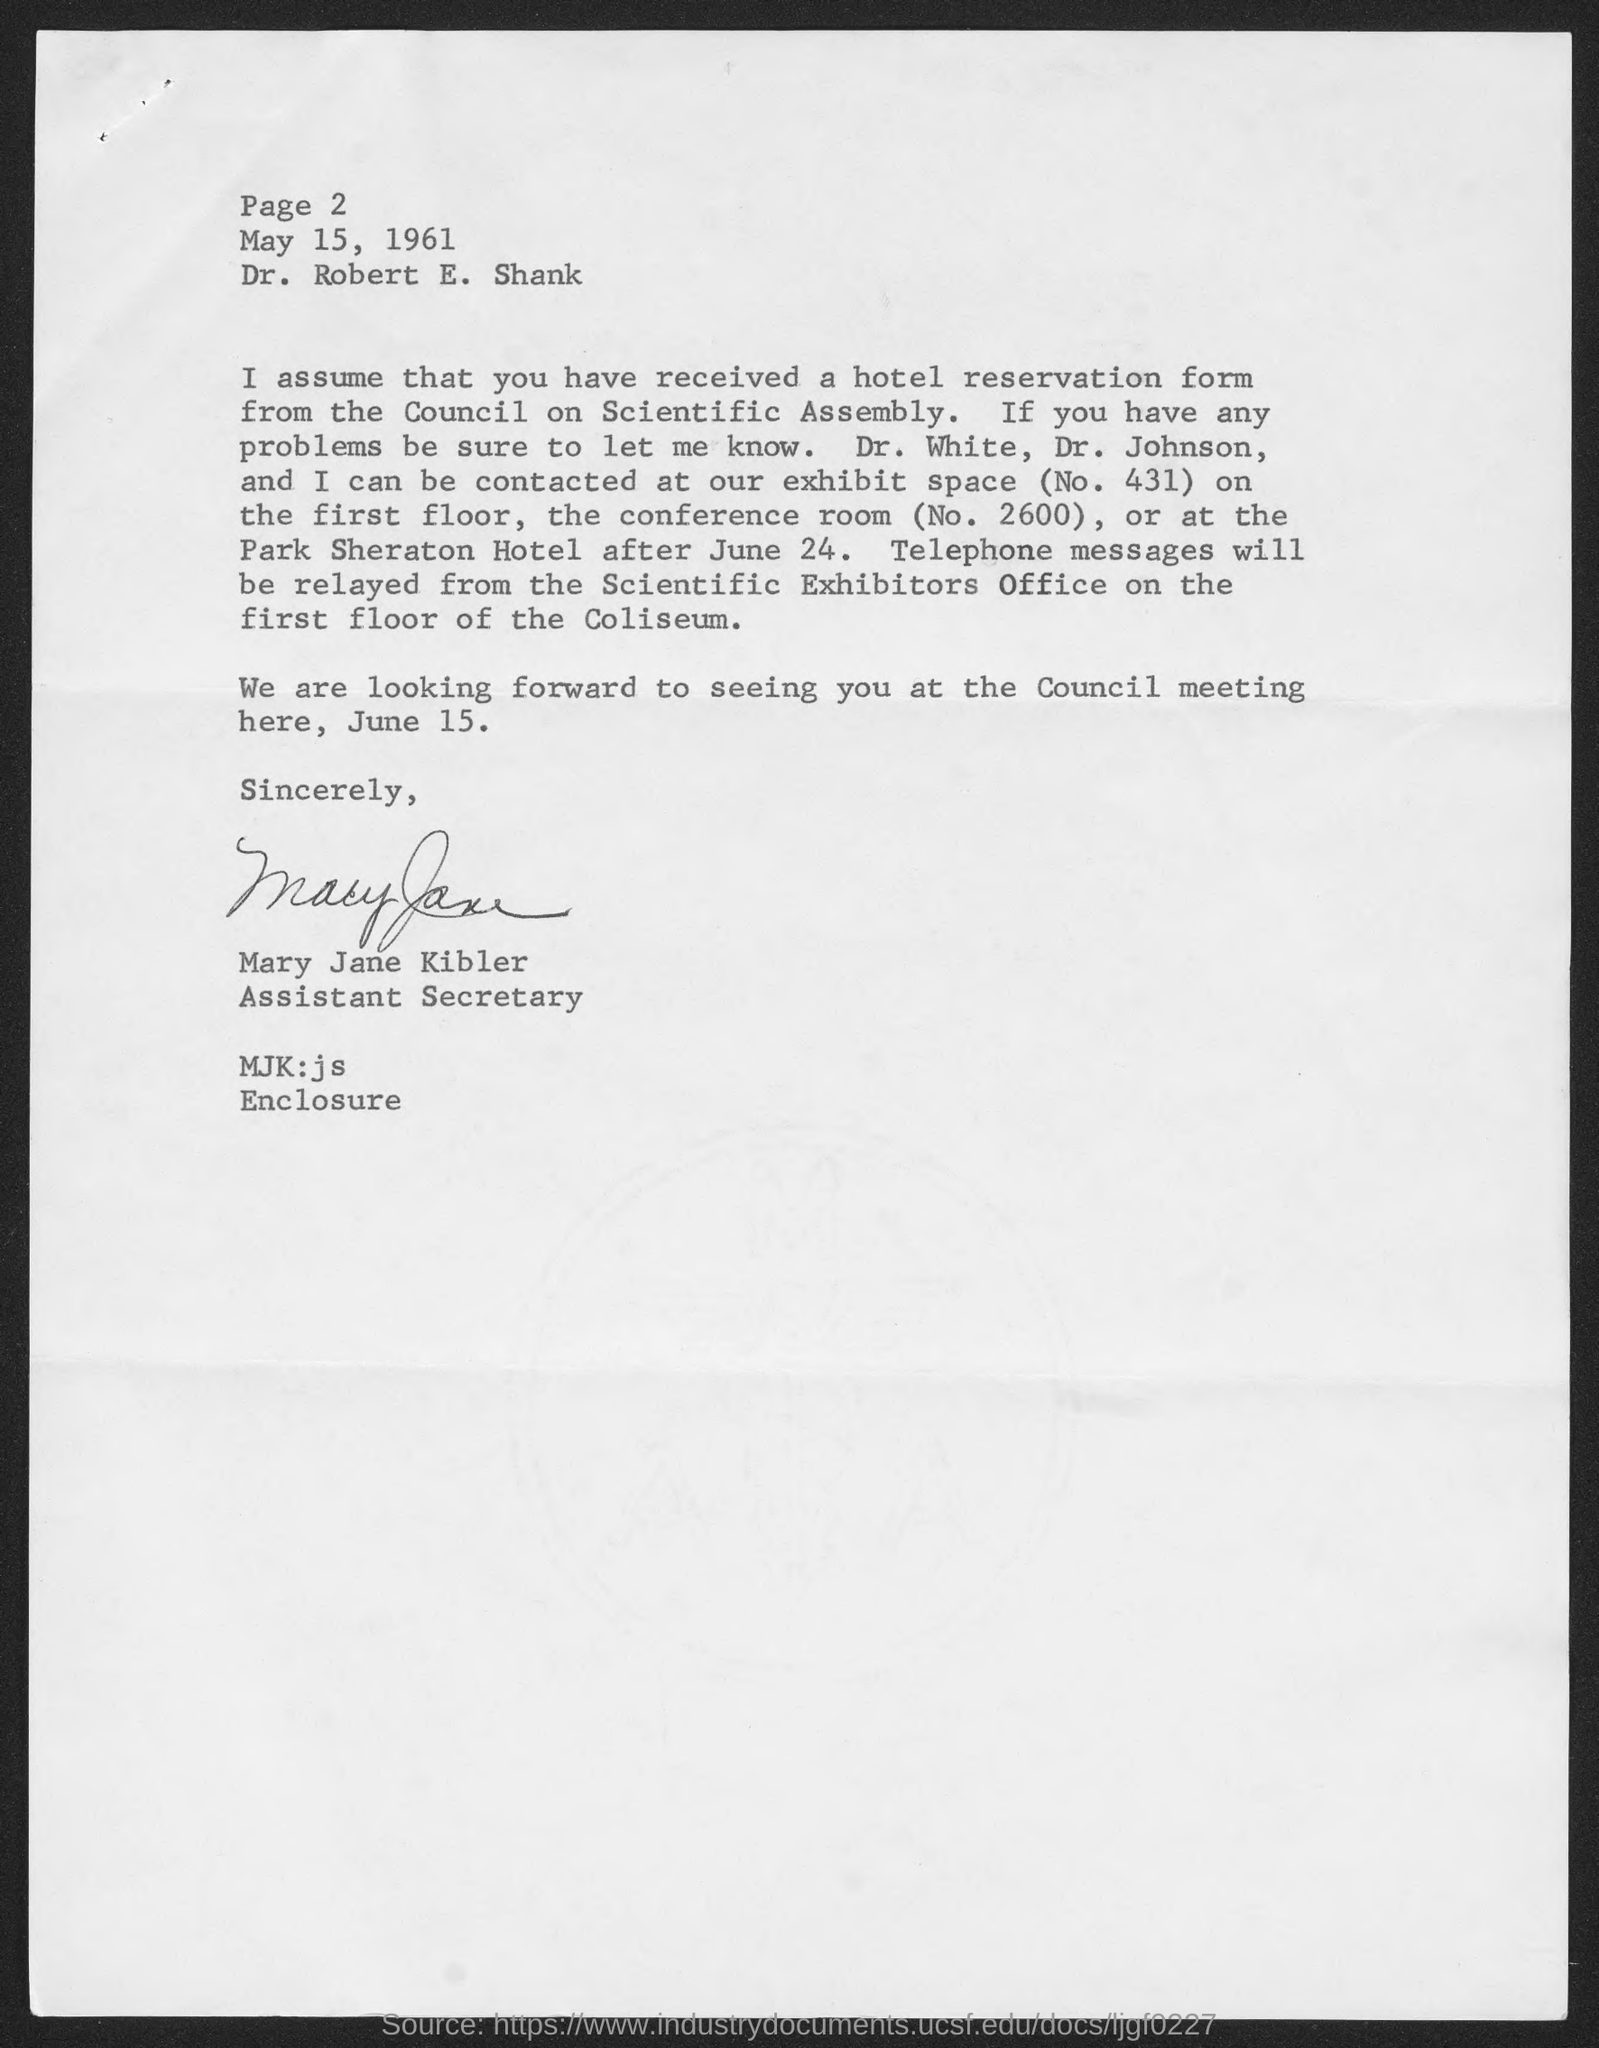What is the date mentioned in this letter?
Your response must be concise. May 15, 1961. Who has signed the letter?
Your answer should be very brief. Mary Jane Kibler. What is the designation of Mary Jane Kibler?
Your answer should be very brief. Assistant Secretary. To whom, the letter is addressed?
Offer a very short reply. Dr. Robert E. Shank. 